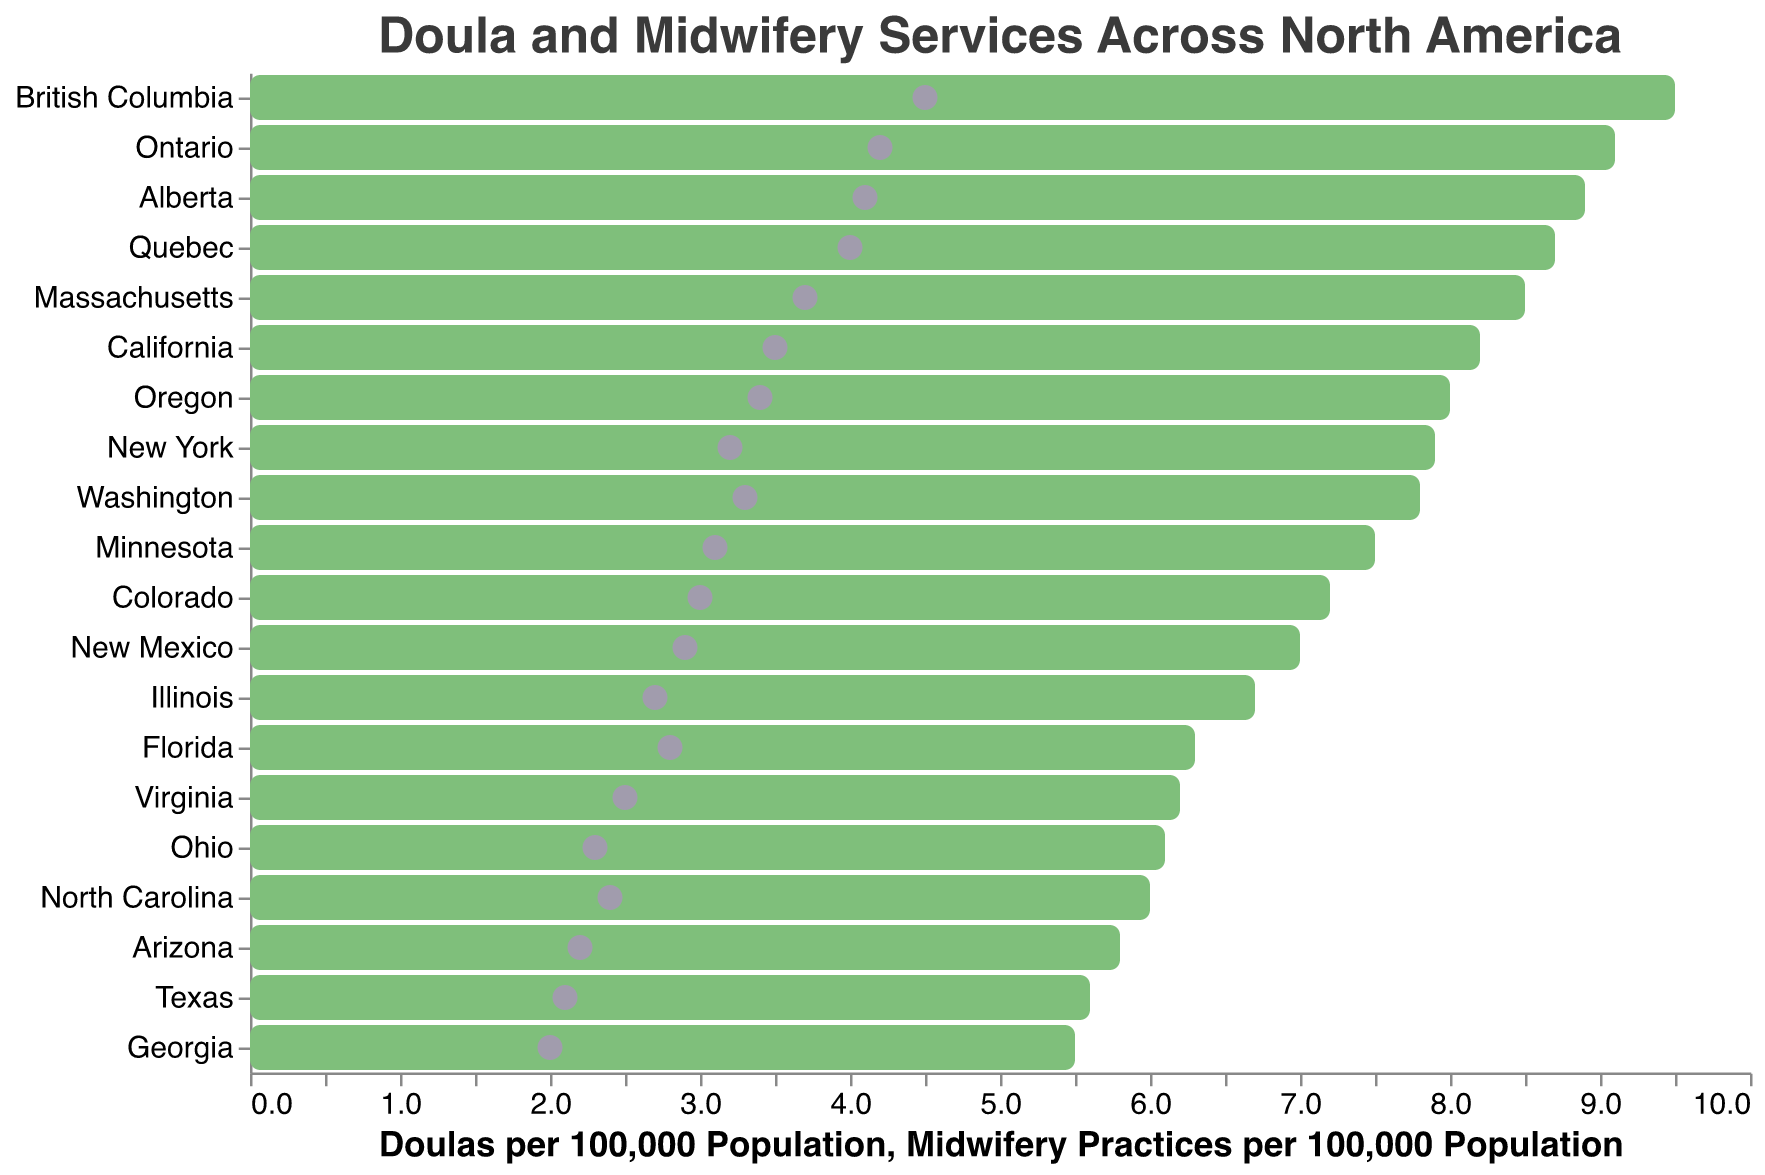What is the title of the plot? The title of the plot is provided at the top of the figure, which gives an overall summary of the content being displayed.
Answer: Doula and Midwifery Services Across North America Which region has the highest number of doulas per 100,000 population? By looking at the leftmost bar, which has the highest value, you can see British Columbia has the highest number of doulas per 100,000 population.
Answer: British Columbia Which regions have more than 8 doulas per 100,000 population? By identifying bars that extend beyond the 8-mark on the x-axis for doulas, we see British Columbia, Ontario, Quebec, Alberta, California, Massachusetts, and New York.
Answer: British Columbia, Ontario, Quebec, Alberta, California, Massachusetts, New York How many regions have more midwifery practices per 100,000 population than doulas? By checking if any circles are positioned to the right of the corresponding bar for each region, no such region appears in the plot indicating all regions have a greater number of doulas compared to midwifery practices per 100,000 population.
Answer: 0 What is the average number of doulas per 100,000 population across all regions? Sum all the values for doulas (8.2 + 7.9 + 5.6 + 6.3 + 9.1 + 8.7 + 9.5 + 7.8 + 8.5 + 7.2 + 8.0 + 7.5 + 6.0 + 5.8 + 8.9 + 6.7 + 6.2 + 5.5 + 6.1 + 7.0) which equals 139.5, then divide by the number of regions, which is 20; 139.5 / 20 = 6.975
Answer: 6.975 Which region has the smallest difference between the number of doulas and midwifery practices per 100,000 population? Calculating the difference for each region and comparing them, we get that Ontario with (9.1 - 4.2) = 4.9 and Quebec with (8.7 - 4.0) = 4.7, and British Columbia with (9.5 - 4.5) = 5.0, among which Quebec has the smallest difference.
Answer: Quebec Is California or Ontario higher in doulas per 100,000 population? By comparing the doulas per 100,000 population for California and Ontario, Ontario is higher with 9.1 compared to California’s 8.2
Answer: Ontario What is the total number of midwifery practices in New York and Texas per 100,000 population? Adding the values for midwifery practices in New York (3.2) and Texas (2.1); 3.2 + 2.1 = 5.3
Answer: 5.3 Which regions have fewer than 6 doulas per 100,000 population? By identifying bars that do not reach the 6-mark on the x-axis for doulas, we see Texas, Georgia, and Arizona.
Answer: Texas, Georgia, Arizona On average, do the Canadian regions have more doulas per 100,000 population than the U.S. regions? First, calculate the average number of doulas for Canadian regions (Ontario, Quebec, British Columbia, Alberta) as (9.1 + 8.7 + 9.5 + 8.9) / 4 = 9.05. Then calculate the average for the U.S. regions from the previous total (139.5 - (9.1 + 8.7 + 9.5 + 8.9) = 103.3) and then find the average (103.3 / 16) = 6.456. 9.05 is greater than 6.456.
Answer: Yes 